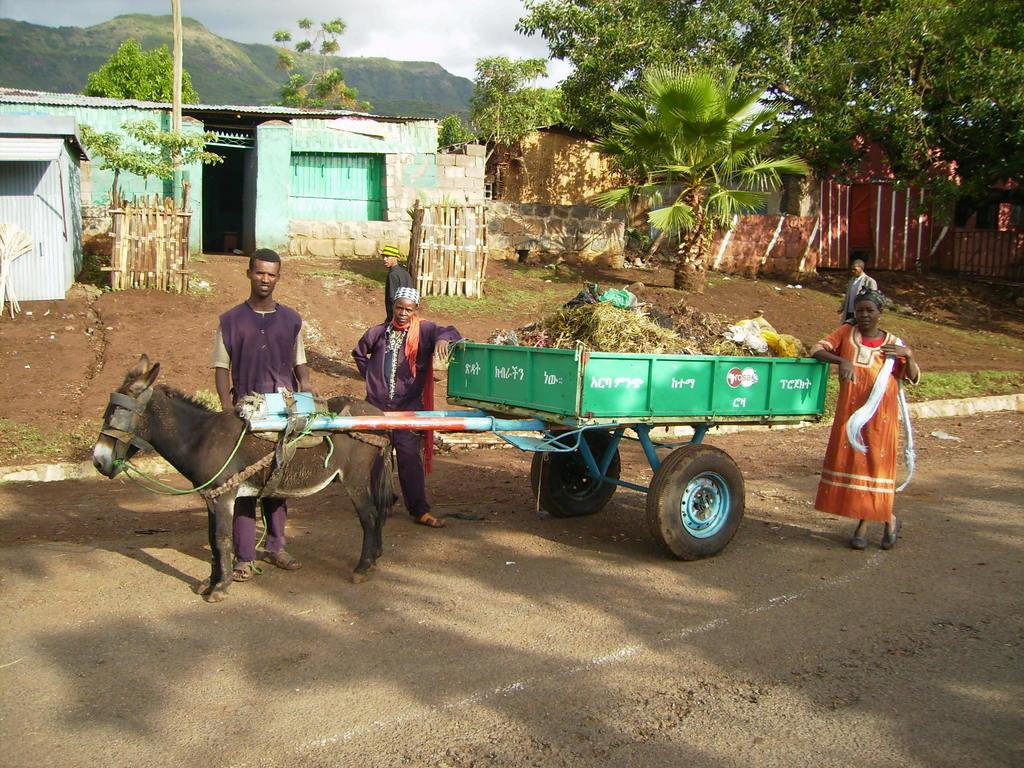What animal is present in the image? There is a donkey in the image. Are there any people in the image? Yes, there are people in the image. What is the donkey pulling in the image? The donkey is pulling a cart in the image. What is inside the cart? The cart contains garbage. What can be seen in the background of the image? There are houses, trees, and hills in the background of the image. What type of mist can be seen surrounding the donkey in the image? There is no mist present in the image; it is a clear day with a visible background. What type of grass is the donkey grazing on in the image? There is no grass present in the image, and the donkey is not grazing; it is pulling a cart. 